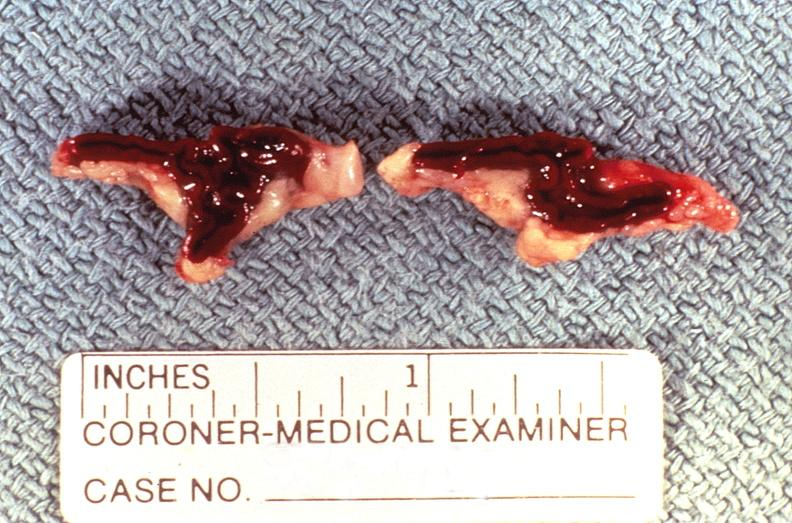s newborn cord around neck present?
Answer the question using a single word or phrase. No 